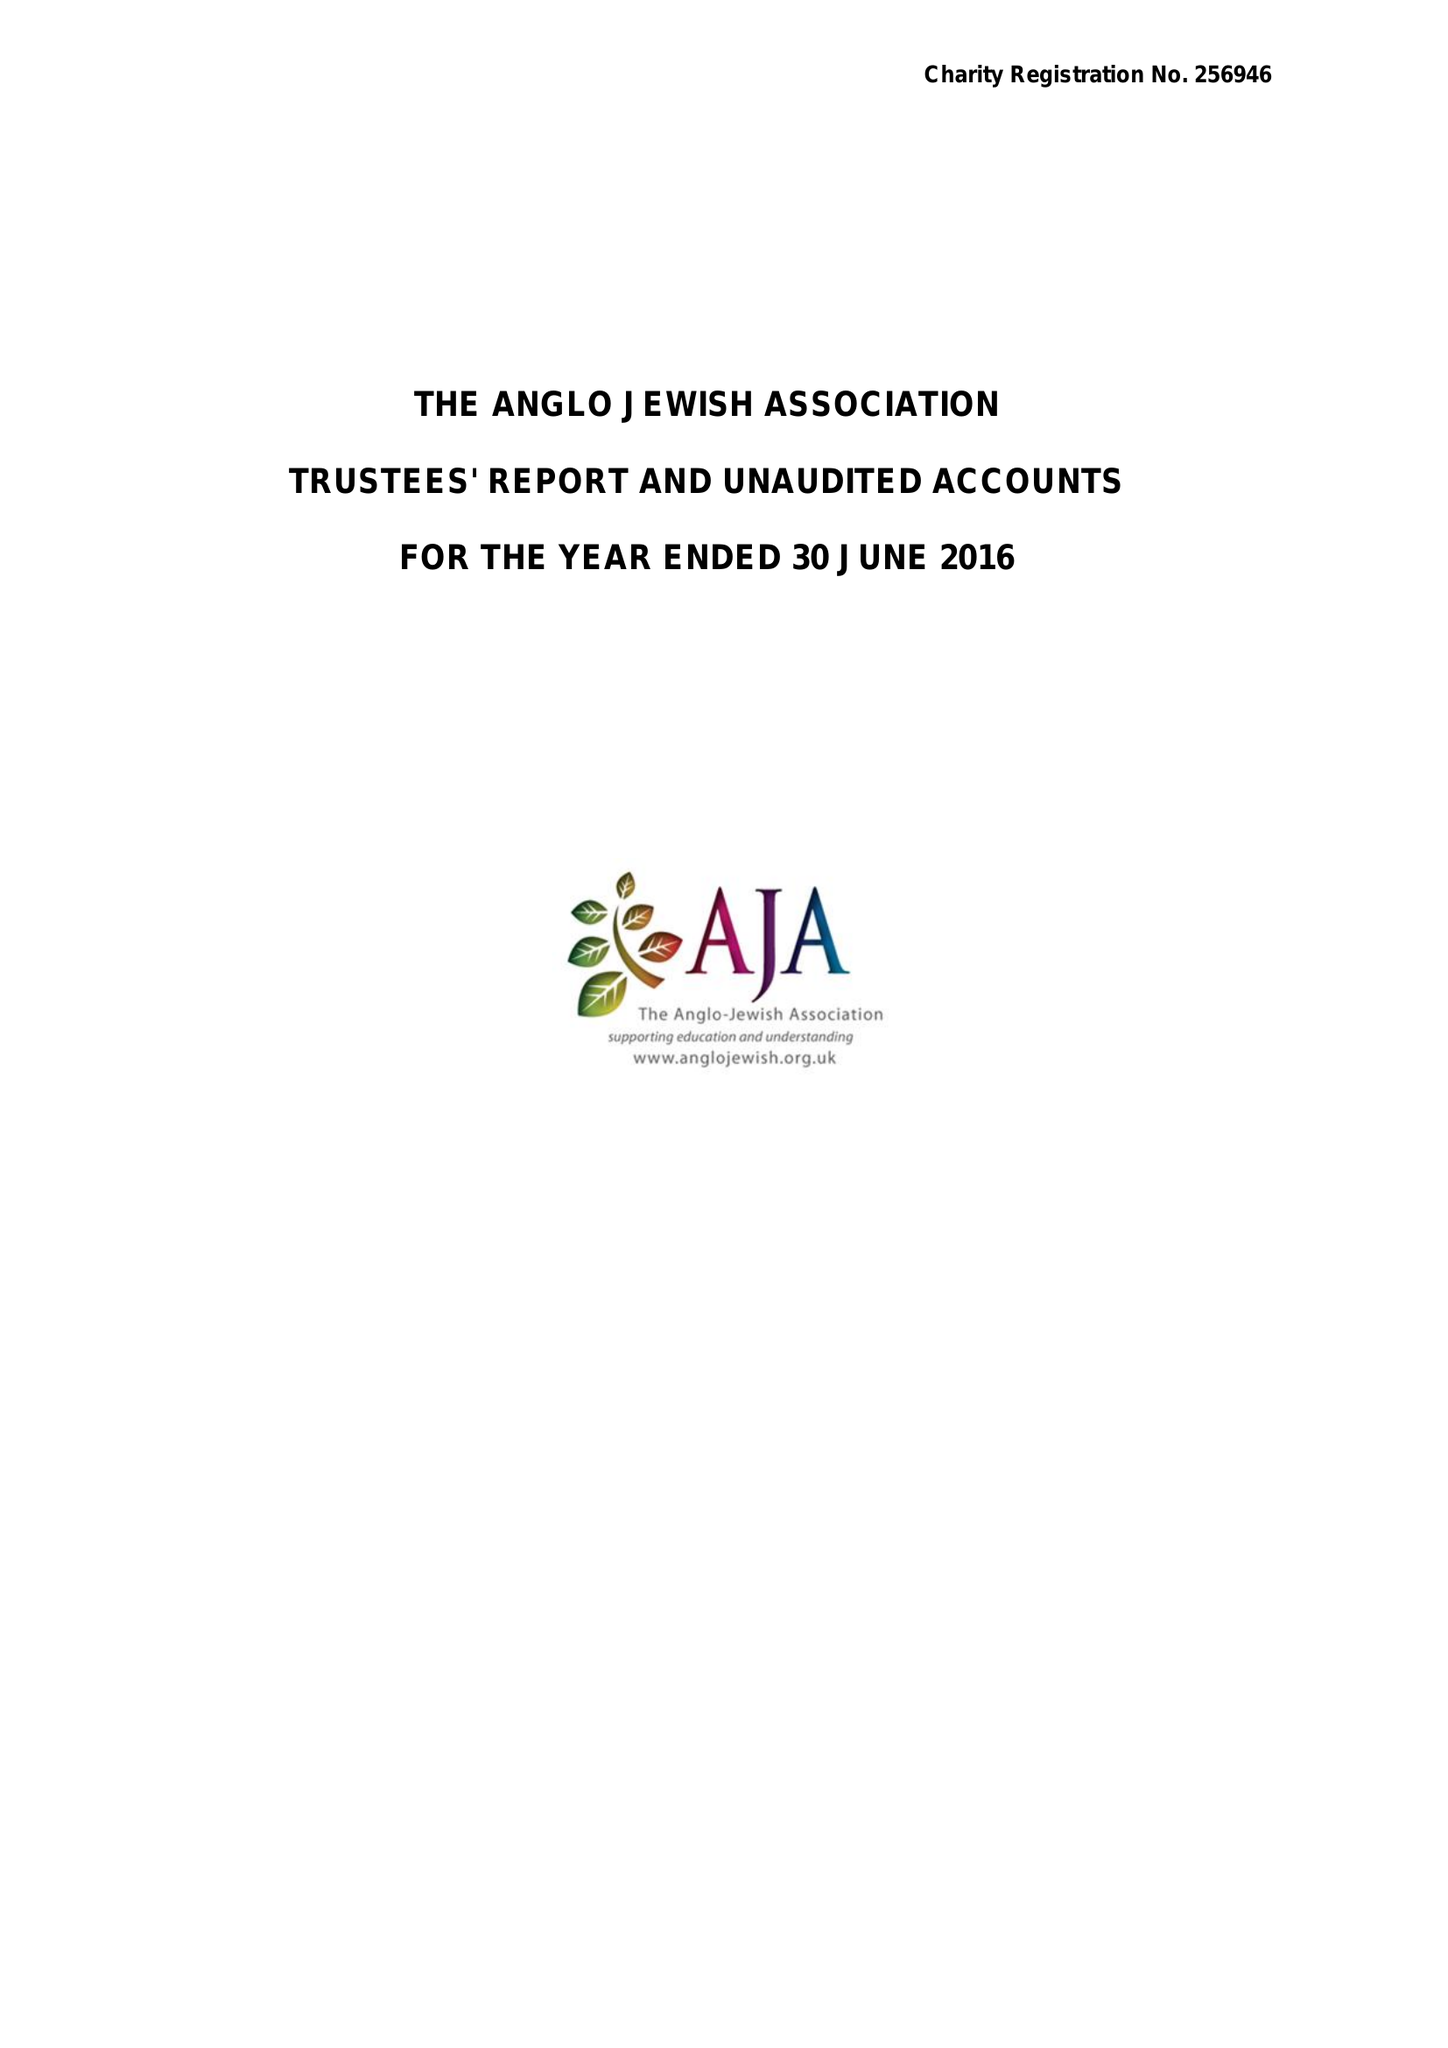What is the value for the address__post_town?
Answer the question using a single word or phrase. LONDON 